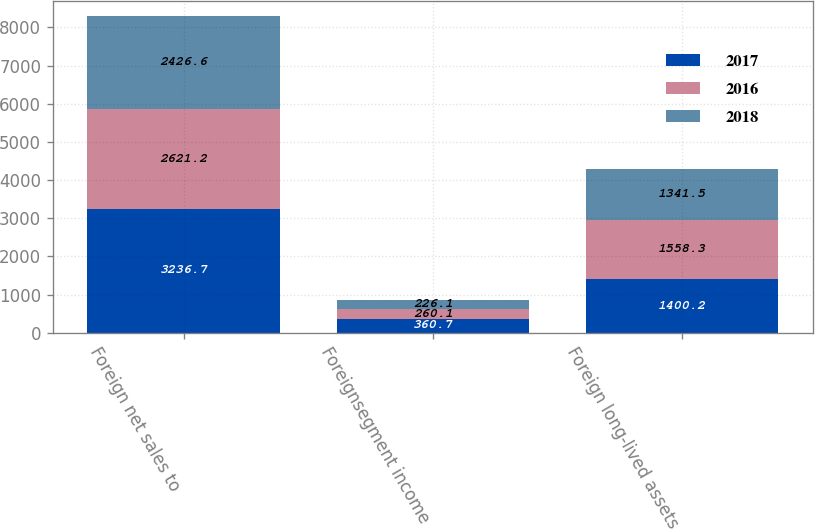Convert chart to OTSL. <chart><loc_0><loc_0><loc_500><loc_500><stacked_bar_chart><ecel><fcel>Foreign net sales to<fcel>Foreignsegment income<fcel>Foreign long-lived assets<nl><fcel>2017<fcel>3236.7<fcel>360.7<fcel>1400.2<nl><fcel>2016<fcel>2621.2<fcel>260.1<fcel>1558.3<nl><fcel>2018<fcel>2426.6<fcel>226.1<fcel>1341.5<nl></chart> 